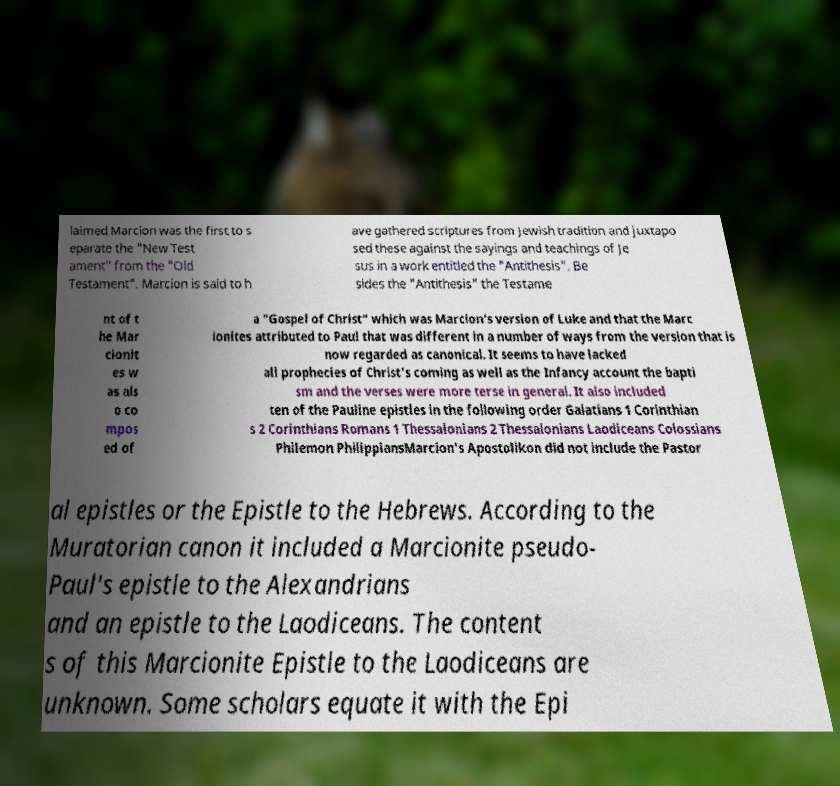For documentation purposes, I need the text within this image transcribed. Could you provide that? laimed Marcion was the first to s eparate the "New Test ament" from the "Old Testament". Marcion is said to h ave gathered scriptures from Jewish tradition and juxtapo sed these against the sayings and teachings of Je sus in a work entitled the "Antithesis". Be sides the "Antithesis" the Testame nt of t he Mar cionit es w as als o co mpos ed of a "Gospel of Christ" which was Marcion's version of Luke and that the Marc ionites attributed to Paul that was different in a number of ways from the version that is now regarded as canonical. It seems to have lacked all prophecies of Christ's coming as well as the Infancy account the bapti sm and the verses were more terse in general. It also included ten of the Pauline epistles in the following order Galatians 1 Corinthian s 2 Corinthians Romans 1 Thessalonians 2 Thessalonians Laodiceans Colossians Philemon PhilippiansMarcion's Apostolikon did not include the Pastor al epistles or the Epistle to the Hebrews. According to the Muratorian canon it included a Marcionite pseudo- Paul's epistle to the Alexandrians and an epistle to the Laodiceans. The content s of this Marcionite Epistle to the Laodiceans are unknown. Some scholars equate it with the Epi 